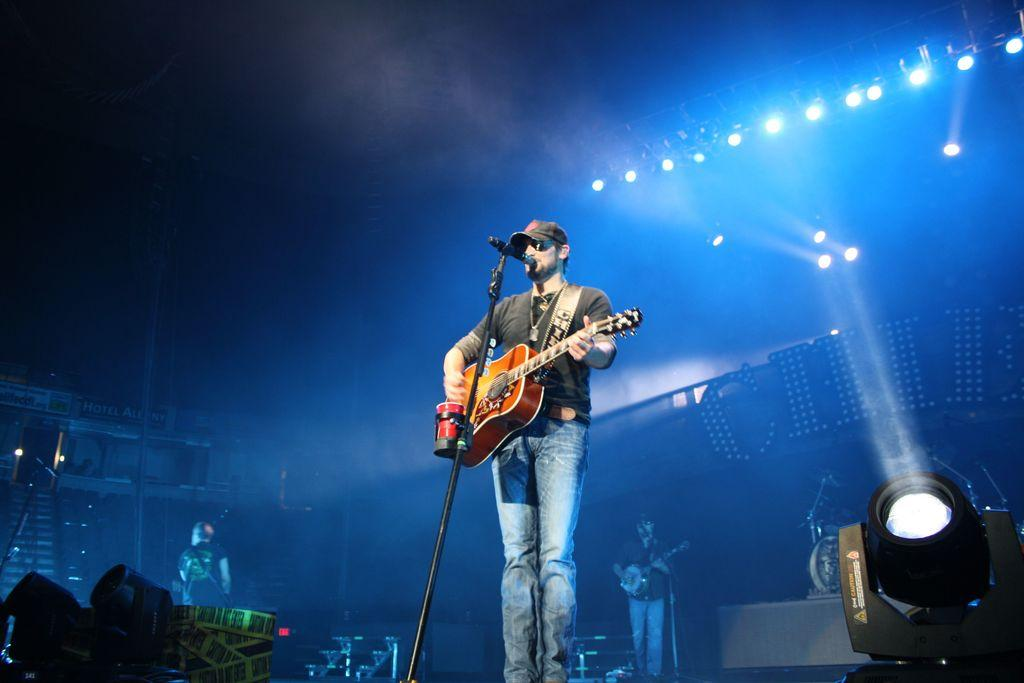Who is present in the image? There is a man in the image. What is the man holding in the image? The man is holding a guitar. What other object can be seen in the image? There is a microphone in the image. What is the size of the sand in the image? There is no sand present in the image. How many rings can be seen on the man's fingers in the image? There is no information about rings on the man's fingers in the image. 